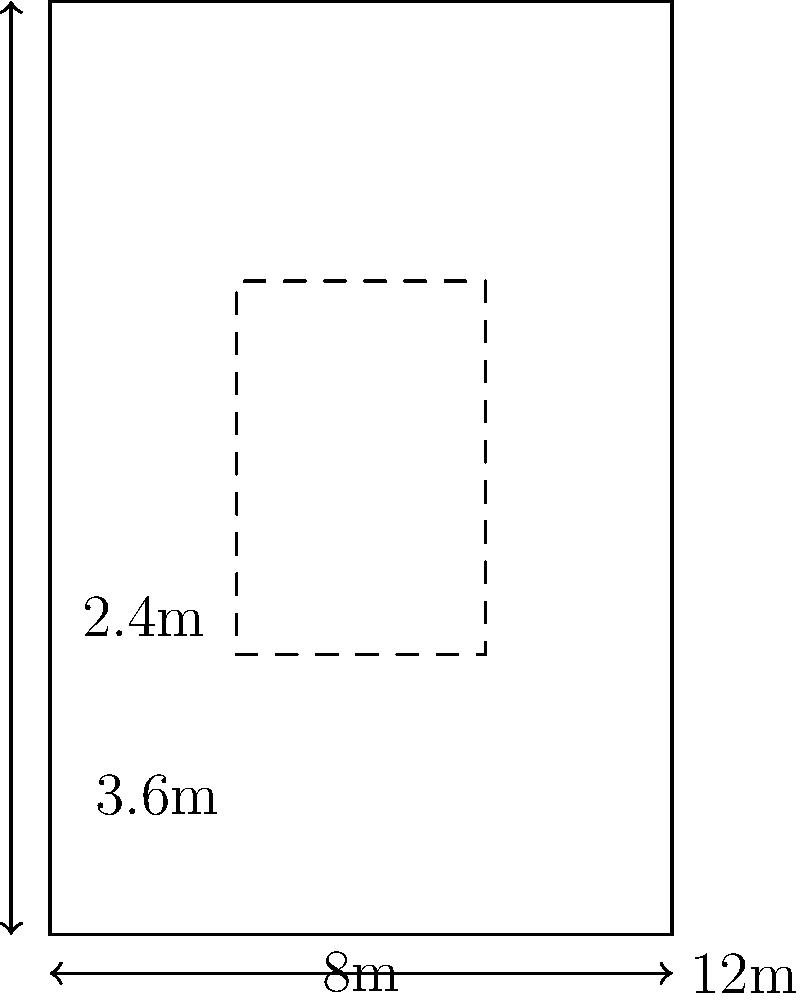As a restaurant owner, you're redesigning your kitchen layout. The kitchen is rectangular, measuring 8m by 12m. You want to create a central workspace, leaving a 2.4m wide pathway around it. What are the dimensions of the largest possible rectangular workspace you can create, and what is its area? Let's approach this step-by-step:

1) The kitchen dimensions are 8m × 12m.

2) We need to leave a 2.4m pathway on all sides. This means:
   - Width of workspace = Total width - (2 × pathway width)
   - Length of workspace = Total length - (2 × pathway width)

3) Calculate the width of the workspace:
   $8 - (2 × 2.4) = 8 - 4.8 = 3.2$ m

4) Calculate the length of the workspace:
   $12 - (2 × 2.4) = 12 - 4.8 = 7.2$ m

5) Therefore, the dimensions of the largest possible rectangular workspace are 3.2m × 7.2m.

6) To calculate the area, multiply the width by the length:
   Area = $3.2 \times 7.2 = 23.04$ m²
Answer: 3.2m × 7.2m, 23.04 m² 